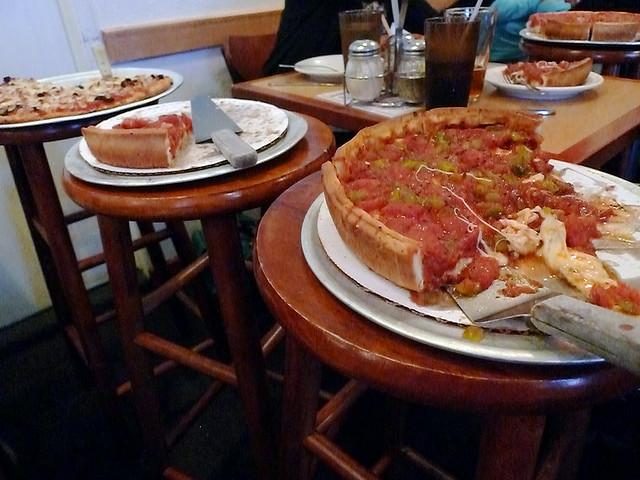Is this in a house?
Short answer required. No. Is this food healthy?
Answer briefly. No. Was there a party?
Answer briefly. Yes. 